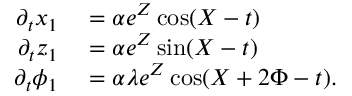Convert formula to latex. <formula><loc_0><loc_0><loc_500><loc_500>\begin{array} { r l } { \partial _ { t } x _ { 1 } } & = \alpha e ^ { Z } \cos ( X - t ) } \\ { \partial _ { t } z _ { 1 } } & = \alpha e ^ { Z } \sin ( X - t ) } \\ { \partial _ { t } \phi _ { 1 } } & = \alpha \lambda e ^ { Z } \cos ( X + 2 \Phi - t ) . } \end{array}</formula> 